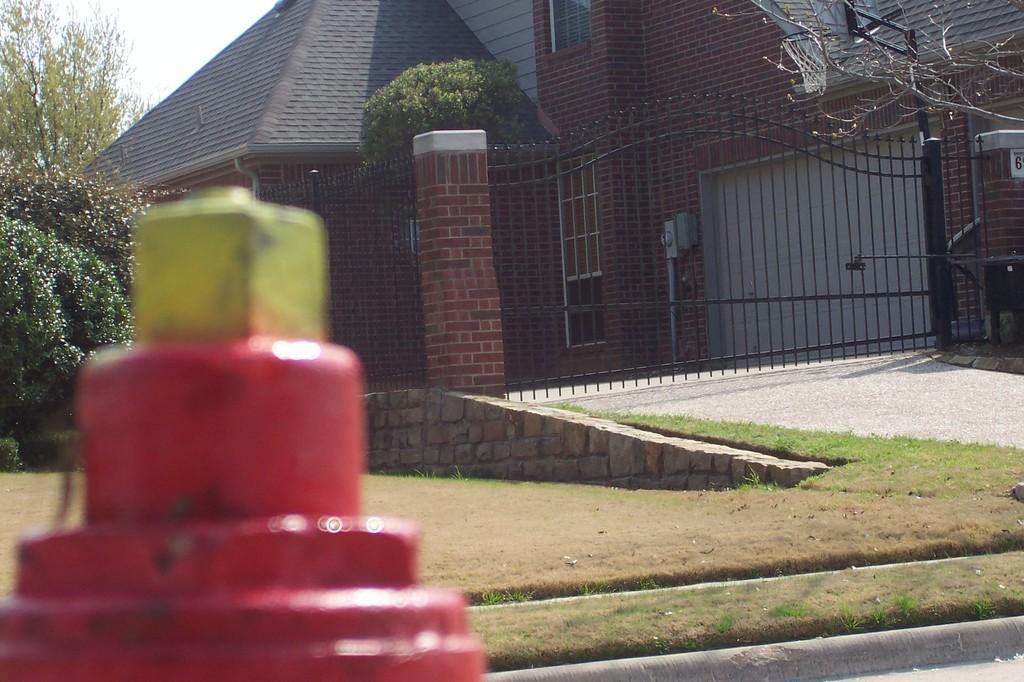Please provide a concise description of this image. In the foreground of this image, on the left it seems like fire hydrant part. In the background, there is gate, buildings, trees, ramp, grass and the sky. 